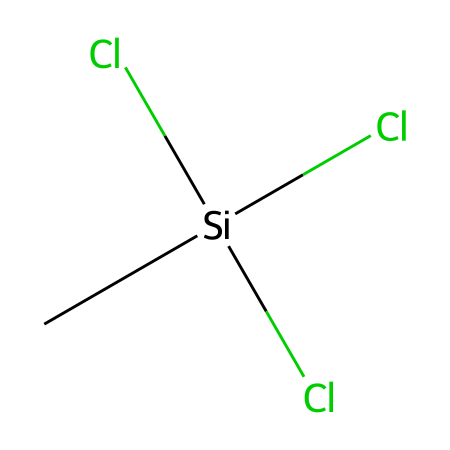What is the total number of chlorine atoms in the structure? The provided SMILES notation indicates the presence of three chlorine atoms, as represented by the three "Cl" in the structure.
Answer: three How many silicon atoms are in the compound? The structure contains one silicon atom, which is denoted by the "Si" in the SMILES representation.
Answer: one What functional group is present in methyltrichlorosilane? The compound is a silane, characterized by the silicon atom bonded to other atoms, specifically three chlorine atoms and a methyl group.
Answer: silane What is the hybridization state of the silicon atom in this structure? The silicon atom is bonded to four substituents (three Cl and one CH3), which implies it adopts an sp3 hybridization state.
Answer: sp3 How does the presence of chlorine atoms affect the reactivity of this silane? The chlorine atoms are highly electronegative and can undergo nucleophilic substitution reactions, increasing the reactivity of the silane compared to silanes with less electronegative groups.
Answer: increases reactivity What is the primary use of methyltrichlorosilane in industrial applications? Methyltrichlorosilane is commonly used to create water-repellent coatings, especially for electronic devices, by forming siloxane networks upon hydrolysis.
Answer: water-repellent coatings How many total bonds involve the silicon atom in this structure? The silicon atom in this molecule forms four bonds: three with chlorine and one with the carbon of the methyl group. Thus, there are four total bonds.
Answer: four 